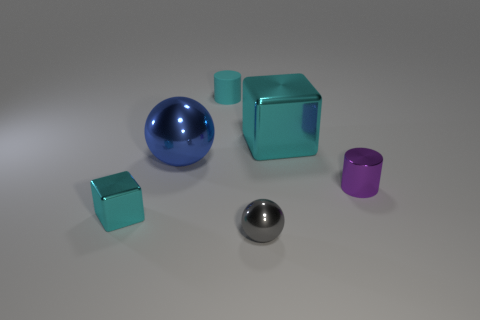Does the blue metal sphere have the same size as the metal cylinder?
Make the answer very short. No. Does the tiny cyan thing that is behind the purple object have the same shape as the cyan shiny thing that is on the left side of the large cyan object?
Your answer should be very brief. No. The blue thing has what size?
Offer a terse response. Large. There is a cyan block that is right of the cyan shiny object that is on the left side of the small cylinder behind the big cyan metal cube; what is its material?
Provide a short and direct response. Metal. How many other objects are there of the same color as the tiny matte thing?
Your answer should be compact. 2. How many blue objects are small matte objects or metallic balls?
Ensure brevity in your answer.  1. What is the material of the cyan thing in front of the big sphere?
Your response must be concise. Metal. Is the cyan cube in front of the big blue ball made of the same material as the blue object?
Provide a succinct answer. Yes. What shape is the large cyan shiny thing?
Your response must be concise. Cube. There is a cyan metallic thing behind the cylinder that is in front of the big cube; what number of rubber things are in front of it?
Your answer should be very brief. 0. 